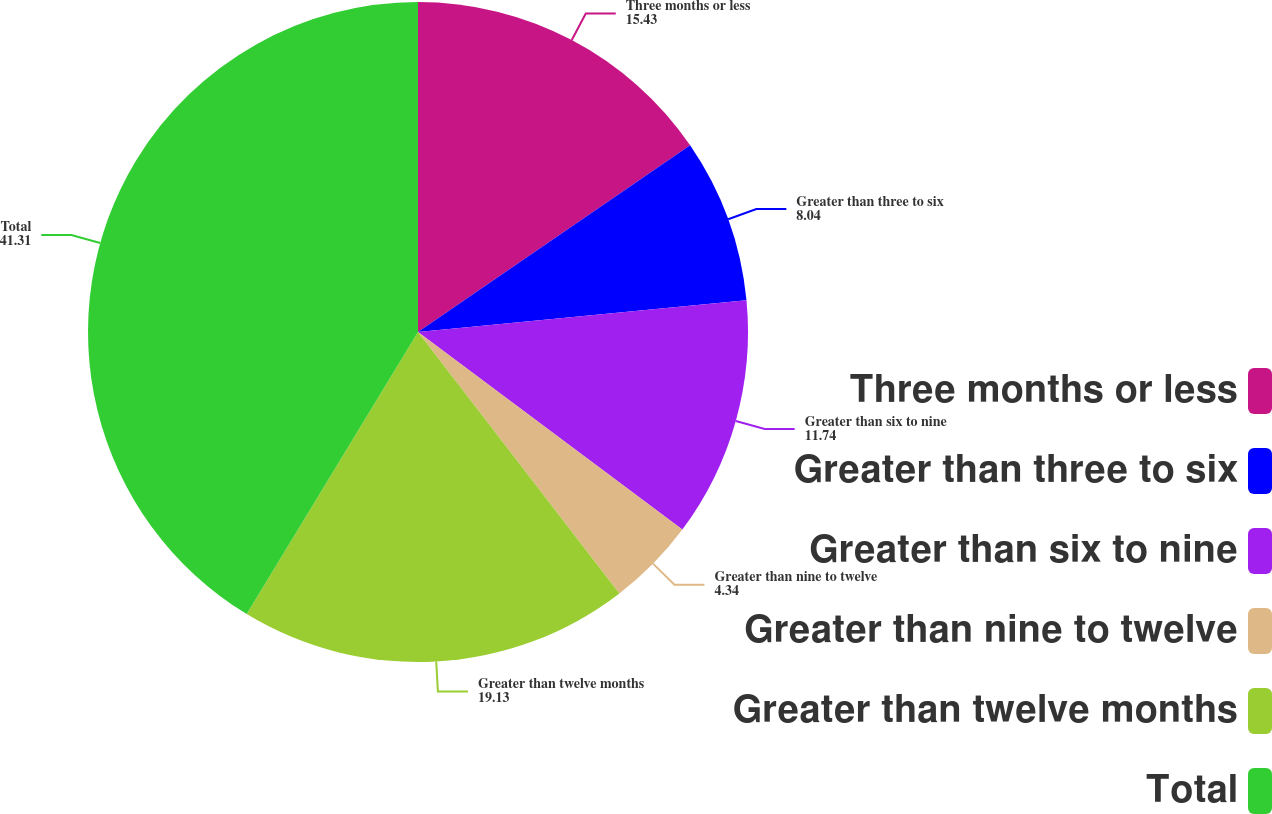Convert chart to OTSL. <chart><loc_0><loc_0><loc_500><loc_500><pie_chart><fcel>Three months or less<fcel>Greater than three to six<fcel>Greater than six to nine<fcel>Greater than nine to twelve<fcel>Greater than twelve months<fcel>Total<nl><fcel>15.43%<fcel>8.04%<fcel>11.74%<fcel>4.34%<fcel>19.13%<fcel>41.31%<nl></chart> 